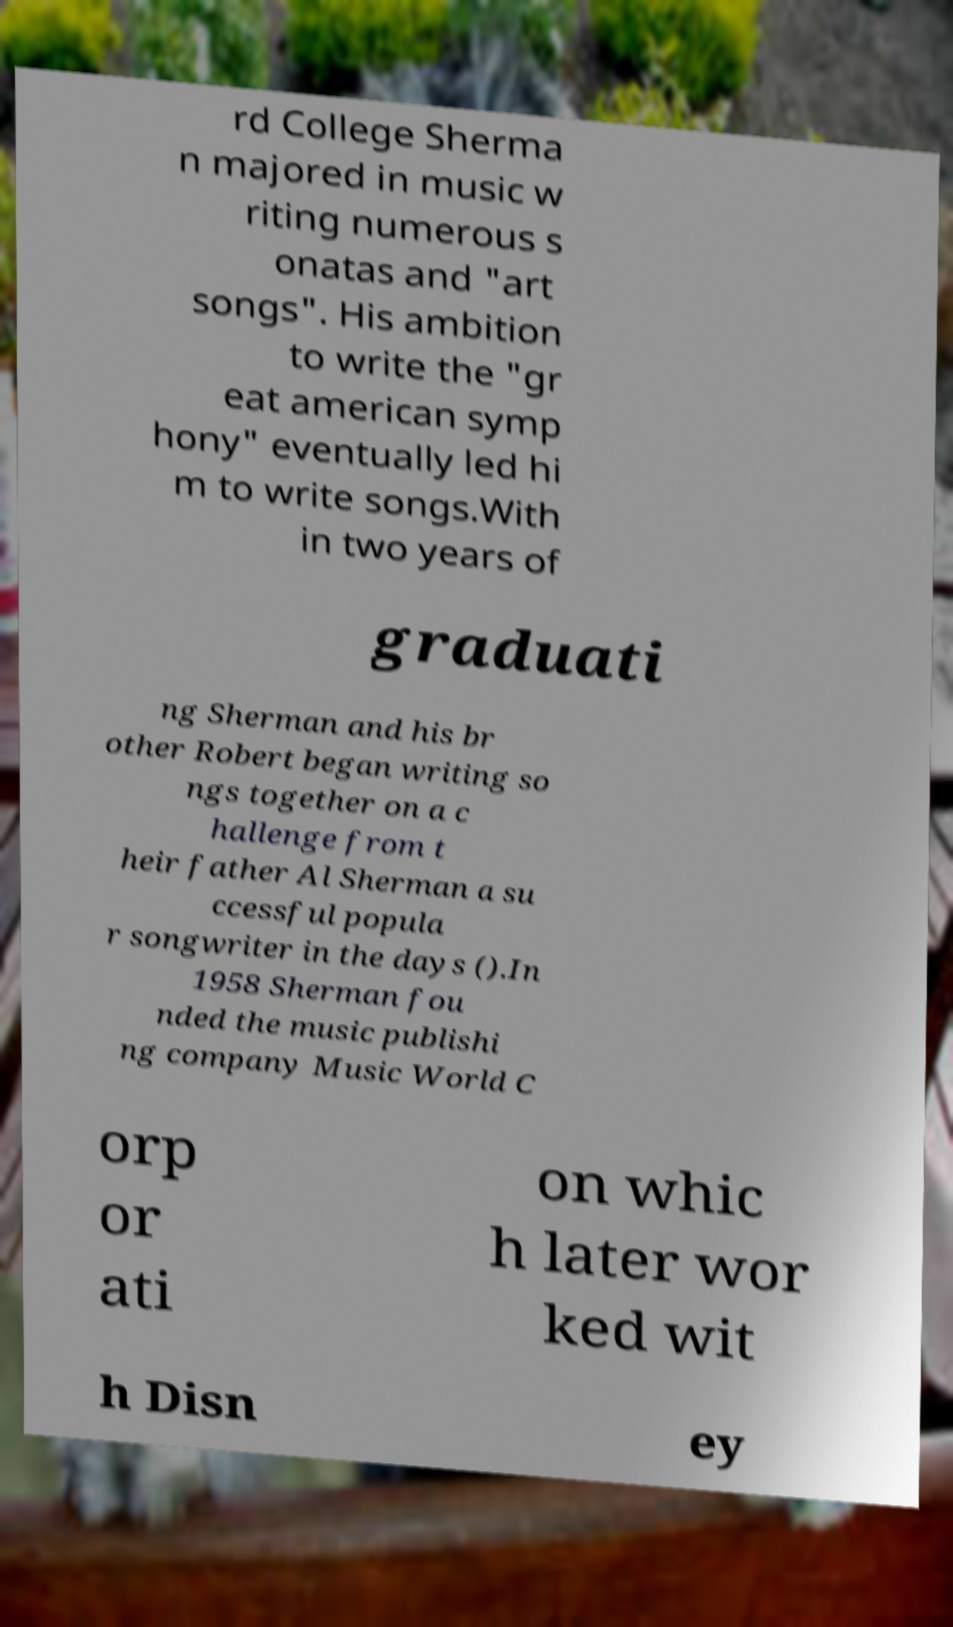For documentation purposes, I need the text within this image transcribed. Could you provide that? rd College Sherma n majored in music w riting numerous s onatas and "art songs". His ambition to write the "gr eat american symp hony" eventually led hi m to write songs.With in two years of graduati ng Sherman and his br other Robert began writing so ngs together on a c hallenge from t heir father Al Sherman a su ccessful popula r songwriter in the days ().In 1958 Sherman fou nded the music publishi ng company Music World C orp or ati on whic h later wor ked wit h Disn ey 